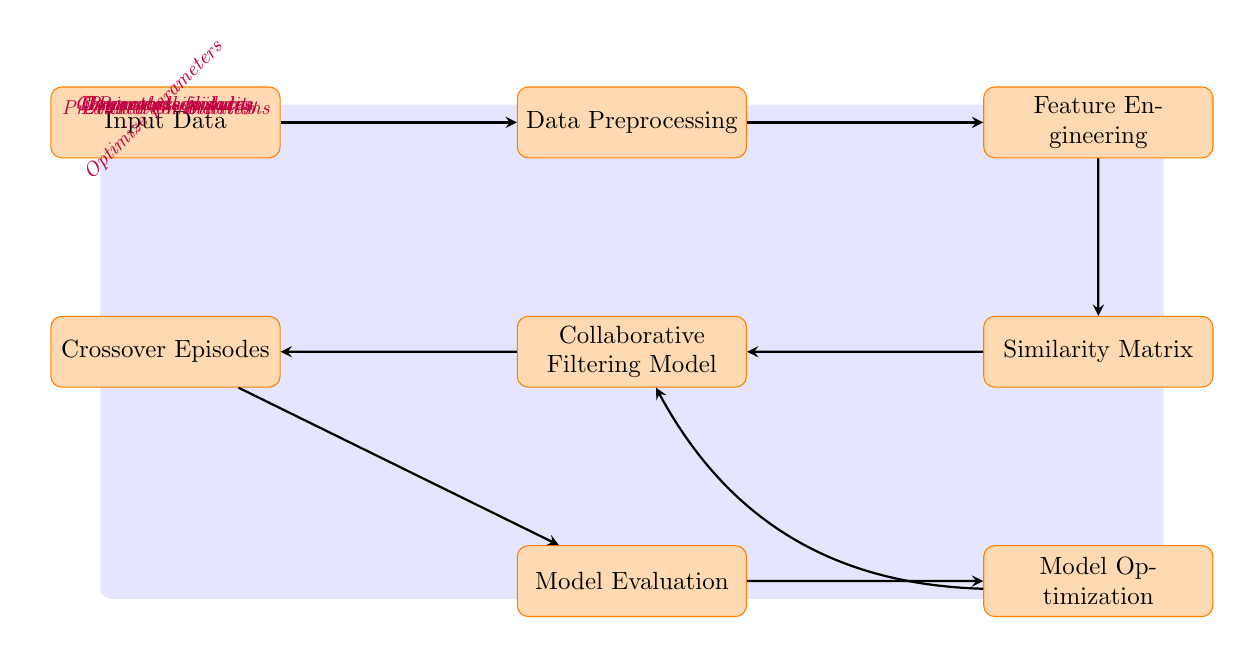What is the first step in the workflow? The first step in the workflow is denoted by the node labeled "Input Data". This shows the starting point where data is introduced into the model.
Answer: Input Data How many main process nodes are in the diagram? The diagram includes seven main process nodes: Input Data, Data Preprocessing, Feature Engineering, Similarity Matrix, Collaborative Filtering Model, Crossover Episodes, and Model Evaluation.
Answer: Seven What type of data is produced after "Feature Engineering"? After the "Feature Engineering" step, the output is referred to as "Engineered features". This indicates that this node's task is to develop features needed for further analysis.
Answer: Engineered features What does the node "Crossover Episodes" generate? The "Crossover Episodes" node produces "Generated episodes", which signifies that this step is focused on creating new episode combinations based on previous analyses.
Answer: Generated episodes What does "Model Optimization" influence? "Model Optimization" influences the "Collaborative Filtering Model", as indicated by the arrow that bends left from "Model Optimization" to "Collaborative Filtering Model." This shows that optimization efforts are directed back to improving the model.
Answer: Collaborative Filtering Model What type of relationships exist between "Similarity Matrix" and "Collaborative Filtering Model"? The relationship between "Similarity Matrix" and "Collaborative Filtering Model" is a direct influence, as the "Similarity Matrix" provides "Character similarity" which informs the collaborative filtering process.
Answer: Direct influence What kind of output is indicated from "Model Evaluation"? The output from "Model Evaluation" is labeled as "Evaluation metrics", which denotes that this step assesses the performance or effectiveness of the collaborative filtering approach used.
Answer: Evaluation metrics Which node indicates the source of raw data? The node indicating the source of raw data is "Input Data", as it represents where all of the data input begins before any processing steps are applied.
Answer: Input Data 